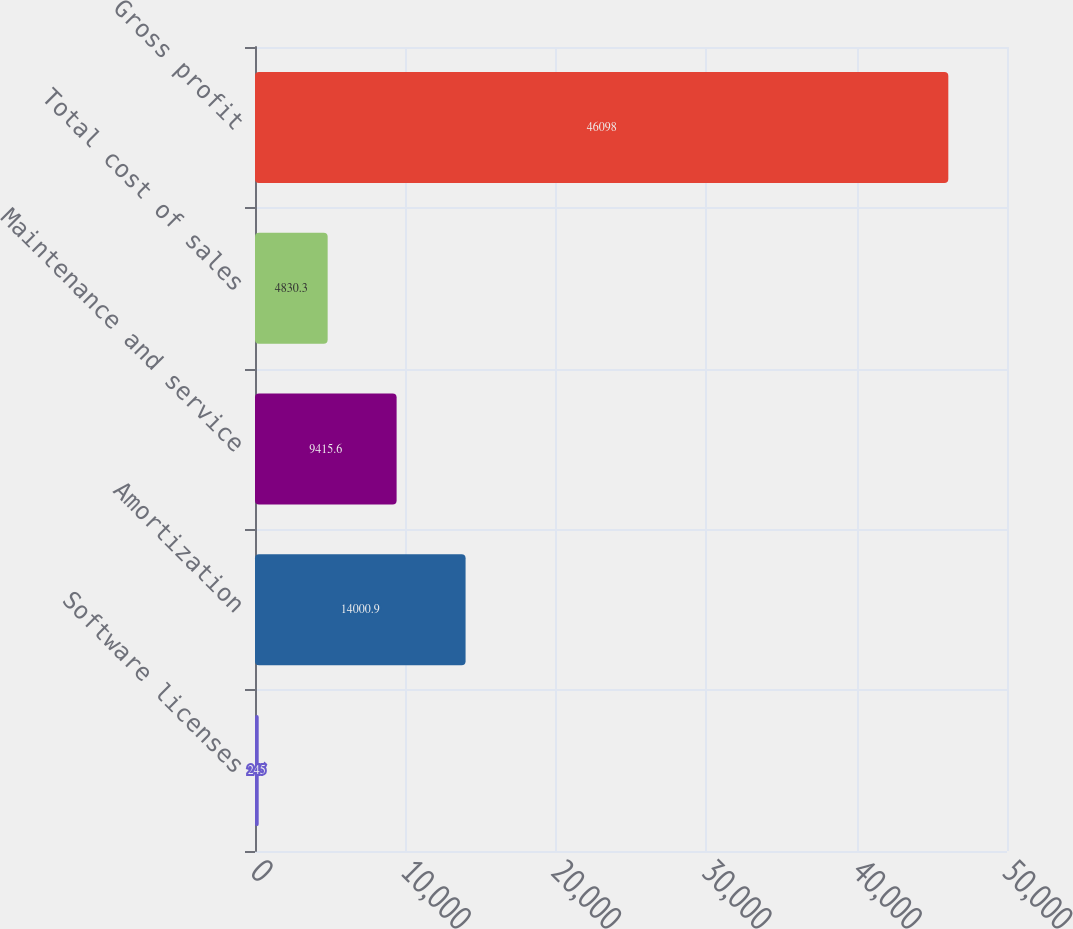Convert chart to OTSL. <chart><loc_0><loc_0><loc_500><loc_500><bar_chart><fcel>Software licenses<fcel>Amortization<fcel>Maintenance and service<fcel>Total cost of sales<fcel>Gross profit<nl><fcel>245<fcel>14000.9<fcel>9415.6<fcel>4830.3<fcel>46098<nl></chart> 